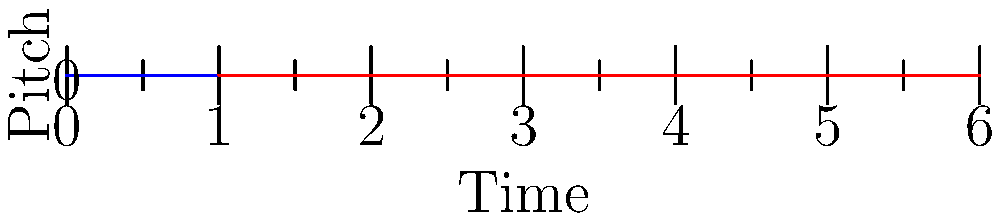As an advocate for artists' rights, you're analyzing two melodic contours to identify potential plagiarism. The blue line represents an original melody, while the red line shows a suspected copy. What machine learning technique would be most appropriate for comparing these melodic contours to detect similarity? To compare melodic contours and detect similarity for potential plagiarism, we need to consider the following steps:

1. Observe the graph: The blue and red lines represent two different melodic contours over time.

2. Analyze the patterns: Both contours show similar shapes and movements, suggesting a potential similarity between the melodies.

3. Consider the data type: We're dealing with sequential data (melody over time), which is a time series.

4. Identify key features: The important aspects are the shape, relative pitch changes, and overall pattern of the contours.

5. Choose an appropriate ML technique: For comparing time series data and detecting similarities, Dynamic Time Warping (DTW) is an excellent choice. DTW can:
   a) Handle variations in tempo between the two melodies
   b) Measure similarity between sequences which may vary in speed or length
   c) Capture the overall shape and pattern of the melodic contours

6. Application of DTW:
   - DTW would align the two sequences (blue and red lines) to find the optimal match
   - It would calculate a similarity score between the two contours
   - This score can be used to determine if the similarity is significant enough to suggest plagiarism

7. Additional considerations: In a real-world scenario, this technique would be combined with other methods (e.g., harmonic analysis, rhythm comparison) for a comprehensive plagiarism detection system.

Given the nature of the data and the task at hand, Dynamic Time Warping (DTW) is the most appropriate machine learning technique for this comparison.
Answer: Dynamic Time Warping (DTW) 